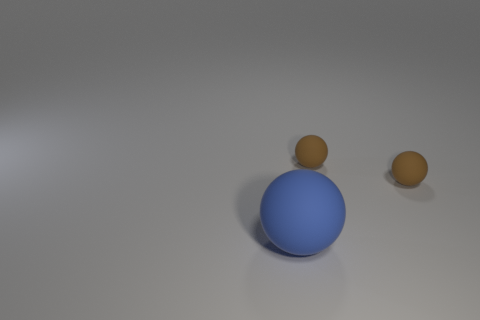What colors are present in the image? The image features a large blue sphere in the center with a glossy texture and two small matte brown spheres. The background is a neutral gray, with some subtle shading giving depth to the scene. 